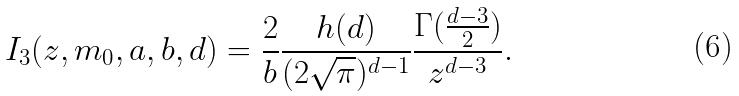<formula> <loc_0><loc_0><loc_500><loc_500>I _ { 3 } ( z , m _ { 0 } , a , b , d ) = \frac { 2 } { b } \frac { h ( d ) } { ( 2 \sqrt { \pi } ) ^ { d - 1 } } \frac { \Gamma ( \frac { d - 3 } { 2 } ) } { z ^ { d - 3 } } .</formula> 